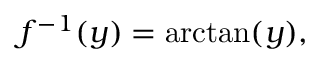<formula> <loc_0><loc_0><loc_500><loc_500>f ^ { - 1 } ( y ) = \arctan ( y ) ,</formula> 